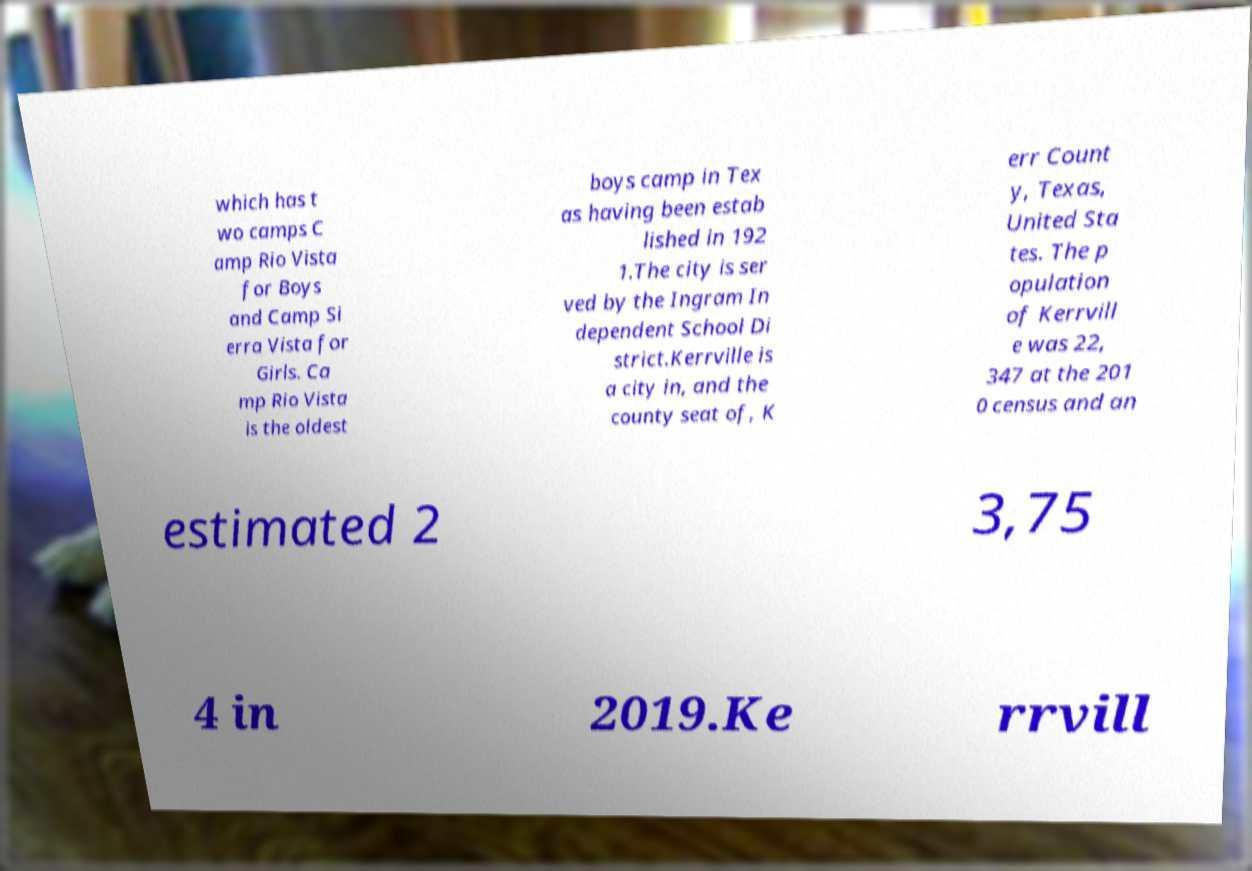What messages or text are displayed in this image? I need them in a readable, typed format. which has t wo camps C amp Rio Vista for Boys and Camp Si erra Vista for Girls. Ca mp Rio Vista is the oldest boys camp in Tex as having been estab lished in 192 1.The city is ser ved by the Ingram In dependent School Di strict.Kerrville is a city in, and the county seat of, K err Count y, Texas, United Sta tes. The p opulation of Kerrvill e was 22, 347 at the 201 0 census and an estimated 2 3,75 4 in 2019.Ke rrvill 